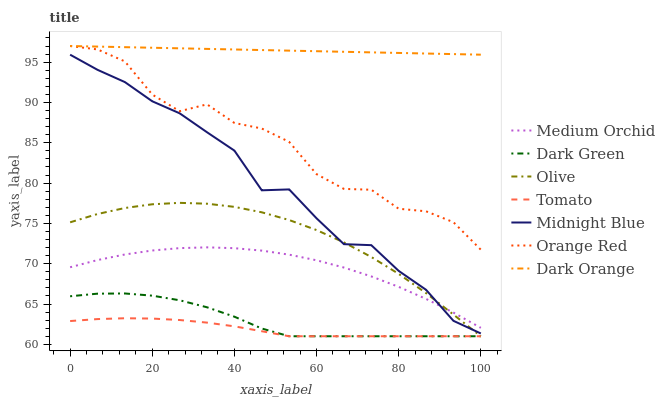Does Tomato have the minimum area under the curve?
Answer yes or no. Yes. Does Dark Orange have the maximum area under the curve?
Answer yes or no. Yes. Does Midnight Blue have the minimum area under the curve?
Answer yes or no. No. Does Midnight Blue have the maximum area under the curve?
Answer yes or no. No. Is Dark Orange the smoothest?
Answer yes or no. Yes. Is Orange Red the roughest?
Answer yes or no. Yes. Is Midnight Blue the smoothest?
Answer yes or no. No. Is Midnight Blue the roughest?
Answer yes or no. No. Does Tomato have the lowest value?
Answer yes or no. Yes. Does Midnight Blue have the lowest value?
Answer yes or no. No. Does Orange Red have the highest value?
Answer yes or no. Yes. Does Midnight Blue have the highest value?
Answer yes or no. No. Is Dark Green less than Midnight Blue?
Answer yes or no. Yes. Is Dark Orange greater than Tomato?
Answer yes or no. Yes. Does Tomato intersect Olive?
Answer yes or no. Yes. Is Tomato less than Olive?
Answer yes or no. No. Is Tomato greater than Olive?
Answer yes or no. No. Does Dark Green intersect Midnight Blue?
Answer yes or no. No. 